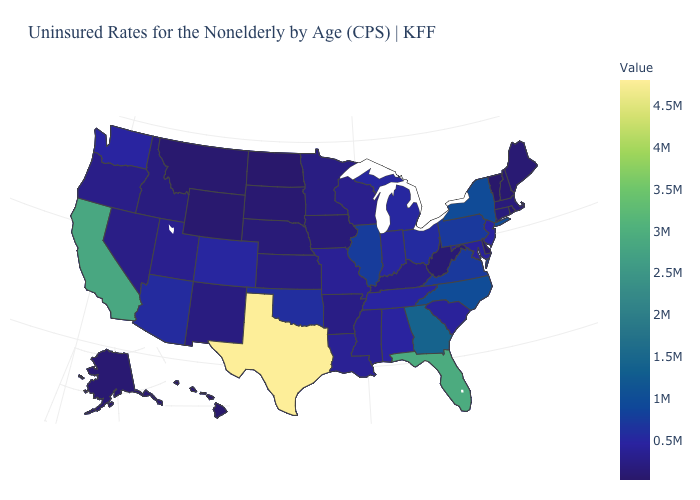Does California have a higher value than Texas?
Answer briefly. No. Among the states that border Montana , does Idaho have the highest value?
Give a very brief answer. Yes. Which states have the lowest value in the USA?
Be succinct. Vermont. Which states have the lowest value in the USA?
Keep it brief. Vermont. Is the legend a continuous bar?
Keep it brief. Yes. 